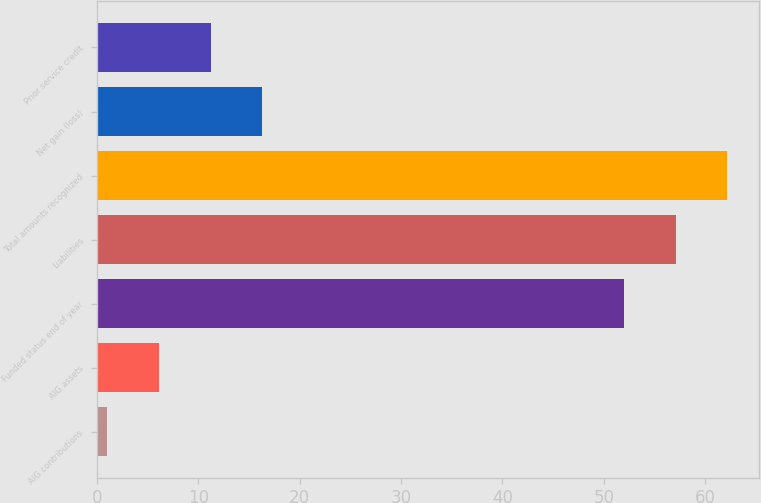<chart> <loc_0><loc_0><loc_500><loc_500><bar_chart><fcel>AIG contributions<fcel>AIG assets<fcel>Funded status end of year<fcel>Liabilities<fcel>Total amounts recognized<fcel>Net gain (loss)<fcel>Prior service credit<nl><fcel>1<fcel>6.1<fcel>52<fcel>57.1<fcel>62.2<fcel>16.3<fcel>11.2<nl></chart> 